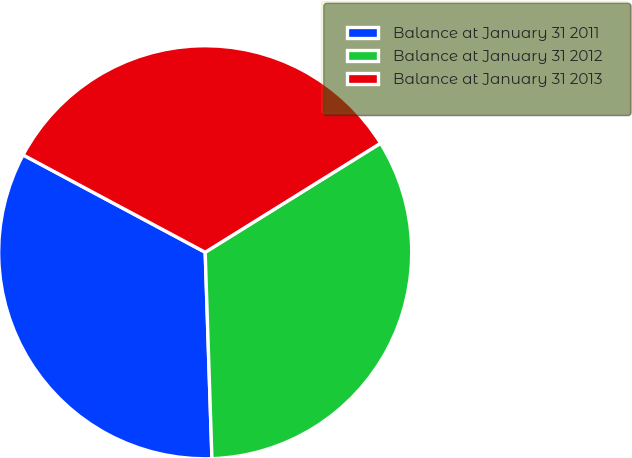<chart> <loc_0><loc_0><loc_500><loc_500><pie_chart><fcel>Balance at January 31 2011<fcel>Balance at January 31 2012<fcel>Balance at January 31 2013<nl><fcel>33.33%<fcel>33.33%<fcel>33.33%<nl></chart> 